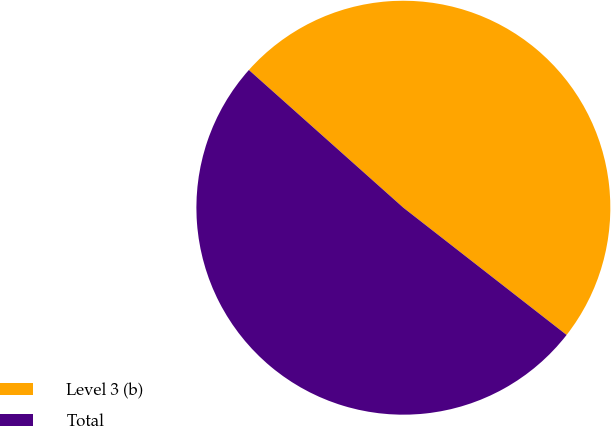Convert chart to OTSL. <chart><loc_0><loc_0><loc_500><loc_500><pie_chart><fcel>Level 3 (b)<fcel>Total<nl><fcel>48.95%<fcel>51.05%<nl></chart> 